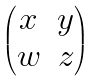Convert formula to latex. <formula><loc_0><loc_0><loc_500><loc_500>\begin{pmatrix} x & y \\ w & z \end{pmatrix}</formula> 